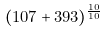<formula> <loc_0><loc_0><loc_500><loc_500>( 1 0 7 + 3 9 3 ) ^ { \frac { 1 0 } { 1 0 } }</formula> 